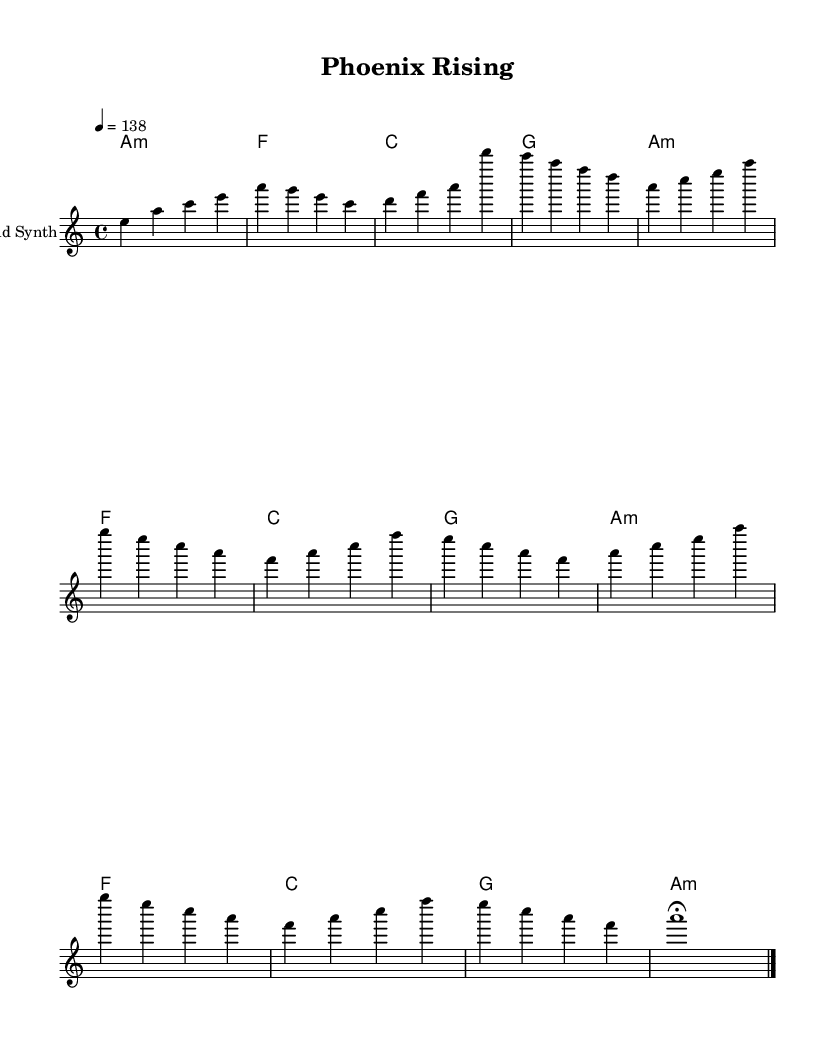What is the key signature of this music? The key signature is A minor, which contains no sharps or flats. It is visually indicated in the sheet music at the beginning.
Answer: A minor What is the time signature in this piece? The time signature is 4/4, indicated at the beginning of the sheet music. It shows there are four beats in a measure and the quarter note gets one beat.
Answer: 4/4 What is the tempo marking of this music? The tempo marking is 138 beats per minute, indicated by the tempo notation at the beginning. It represents a moderately fast tempo.
Answer: 138 How many measures are in the verse section? There are four measures in the verse section, as the section is separated visually from other sections by double bar lines. Each set of notes corresponds to a measure.
Answer: 4 What chord is played during the chorus? The chorus section prominently features the A minor chord, repeated multiple times throughout that section in the chord changes.
Answer: A minor What type of synthesizer is indicated as playing the melody? The instrument indicated for the melody is a "Lead Synth," which is commonly used in electronic music for its bright, engaging tones, making it ideal for uplifting tracks.
Answer: Lead Synth How does the outro differ from the verse and chorus? The outro is simplified to just one long note with a fermata, contrasting with the more rhythmic and complex structures of the verse and chorus sections, indicating a closing feeling.
Answer: Simplified 